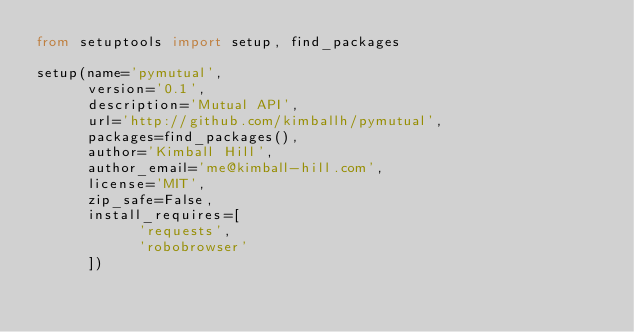<code> <loc_0><loc_0><loc_500><loc_500><_Python_>from setuptools import setup, find_packages

setup(name='pymutual',
      version='0.1',
      description='Mutual API',
      url='http://github.com/kimballh/pymutual',
      packages=find_packages(),
      author='Kimball Hill',
      author_email='me@kimball-hill.com',
      license='MIT',
      zip_safe=False,
      install_requires=[
            'requests',
            'robobrowser'
      ])
</code> 